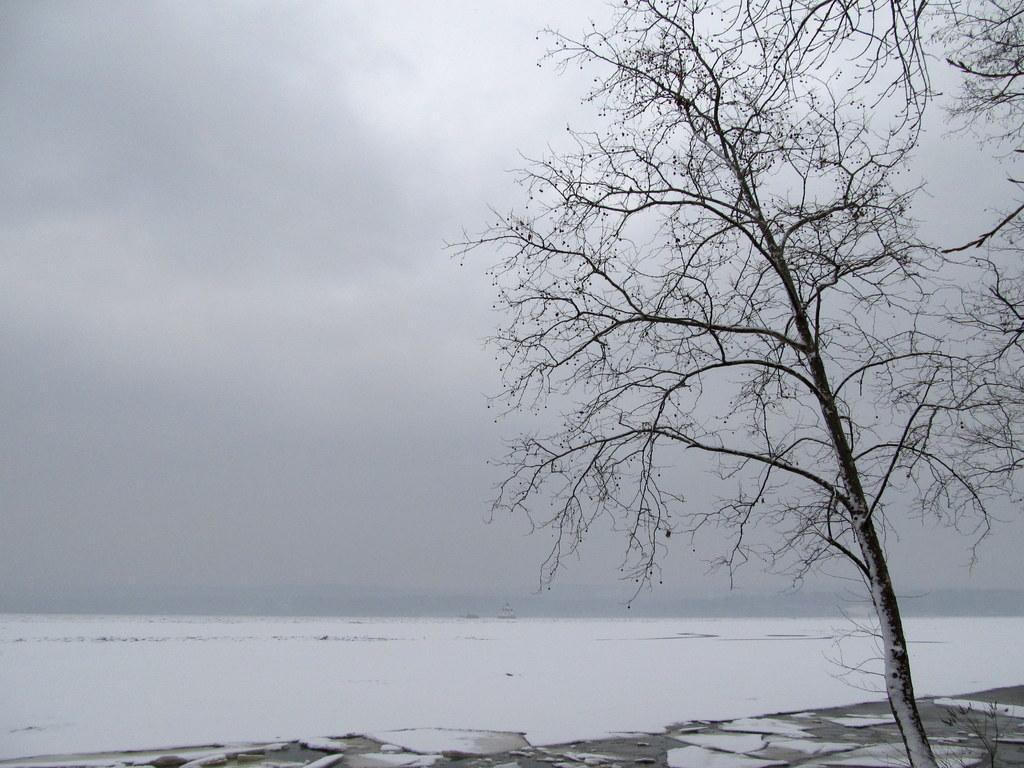Describe this image in one or two sentences. In this image we can see a snow and a tree in front of the image. We can see clouds in the sky. 